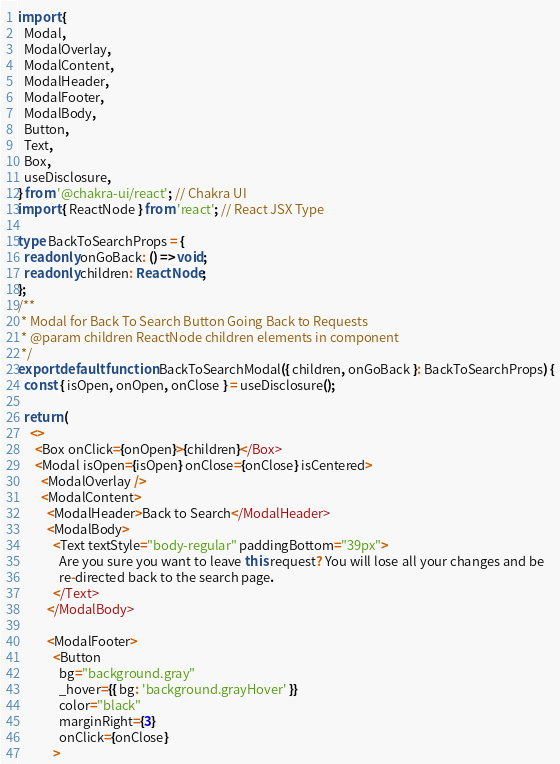<code> <loc_0><loc_0><loc_500><loc_500><_TypeScript_>import {
  Modal,
  ModalOverlay,
  ModalContent,
  ModalHeader,
  ModalFooter,
  ModalBody,
  Button,
  Text,
  Box,
  useDisclosure,
} from '@chakra-ui/react'; // Chakra UI
import { ReactNode } from 'react'; // React JSX Type

type BackToSearchProps = {
  readonly onGoBack: () => void;
  readonly children: ReactNode;
};
/**
 * Modal for Back To Search Button Going Back to Requests
 * @param children ReactNode children elements in component
 */
export default function BackToSearchModal({ children, onGoBack }: BackToSearchProps) {
  const { isOpen, onOpen, onClose } = useDisclosure();

  return (
    <>
      <Box onClick={onOpen}>{children}</Box>
      <Modal isOpen={isOpen} onClose={onClose} isCentered>
        <ModalOverlay />
        <ModalContent>
          <ModalHeader>Back to Search</ModalHeader>
          <ModalBody>
            <Text textStyle="body-regular" paddingBottom="39px">
              Are you sure you want to leave this request? You will lose all your changes and be
              re-directed back to the search page.
            </Text>
          </ModalBody>

          <ModalFooter>
            <Button
              bg="background.gray"
              _hover={{ bg: 'background.grayHover' }}
              color="black"
              marginRight={3}
              onClick={onClose}
            ></code> 